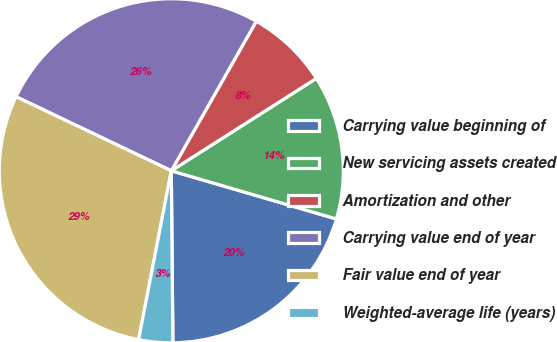<chart> <loc_0><loc_0><loc_500><loc_500><pie_chart><fcel>Carrying value beginning of<fcel>New servicing assets created<fcel>Amortization and other<fcel>Carrying value end of year<fcel>Fair value end of year<fcel>Weighted-average life (years)<nl><fcel>20.33%<fcel>13.55%<fcel>7.74%<fcel>26.14%<fcel>29.04%<fcel>3.19%<nl></chart> 